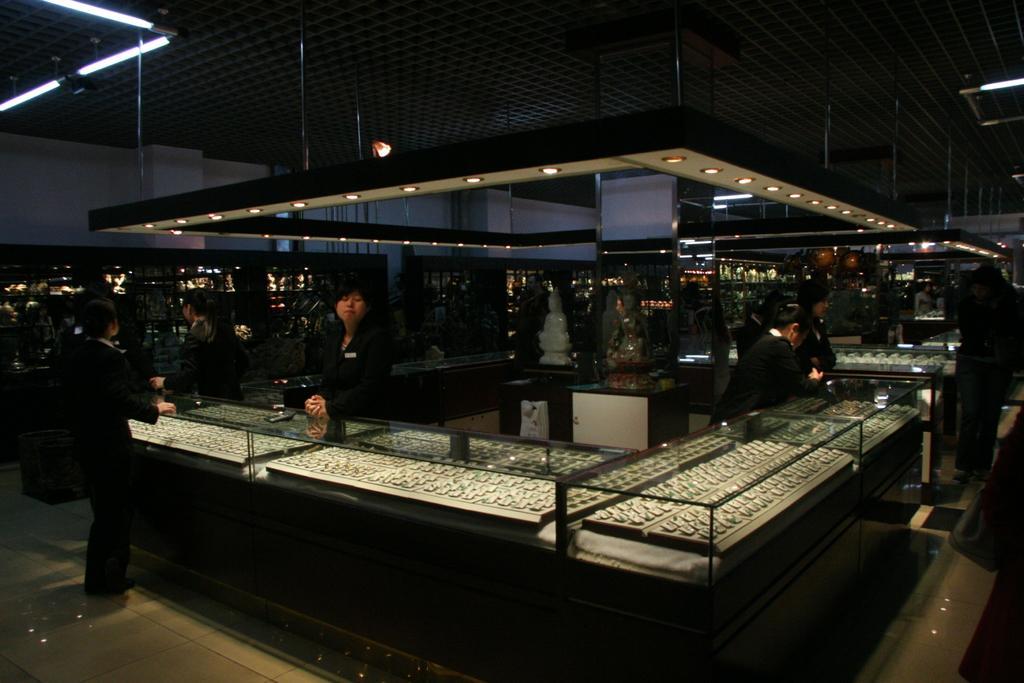Please provide a concise description of this image. In this picture we can see the inside view of the jewelry shop. In the front we can see a woman wearing a black suit and standing near the table. In the front there is a glass table with some jewelry in the box. On the top there is a spot lights hanging from the ceiling. Behind there is a dark background. 